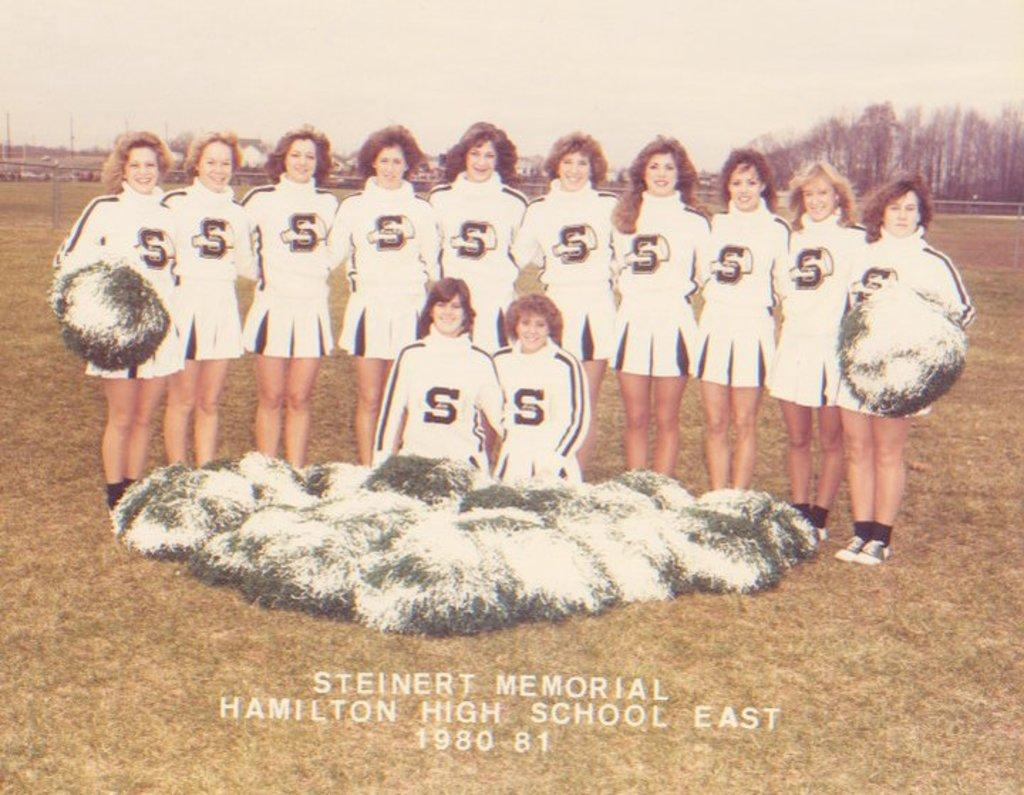<image>
Offer a succinct explanation of the picture presented. A group of cheerleaders from Steinert Memorial Hamilton High School East. 